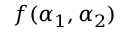Convert formula to latex. <formula><loc_0><loc_0><loc_500><loc_500>f ( \alpha _ { 1 } , \alpha _ { 2 } )</formula> 